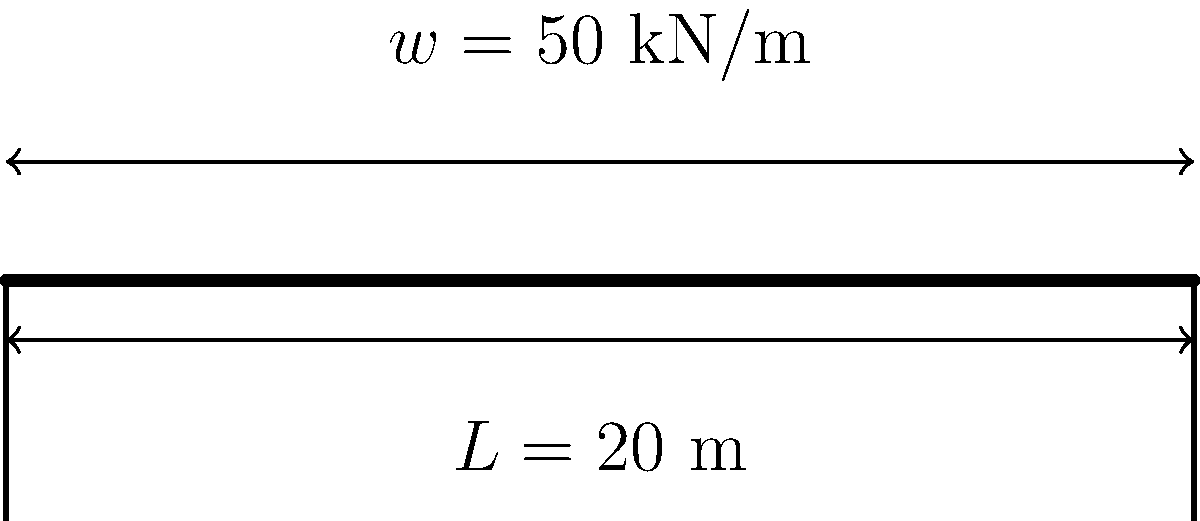A simple supported bridge has a span of 20 meters and is subjected to a uniformly distributed load of 50 kN/m along its entire length. What is the maximum bending moment in the bridge? To calculate the maximum bending moment in a simply supported beam with a uniformly distributed load, we can follow these steps:

1. Identify the given information:
   - Span length, $L = 20$ m
   - Uniformly distributed load, $w = 50$ kN/m

2. The maximum bending moment for a simply supported beam with a uniformly distributed load occurs at the midspan and is given by the formula:

   $M_{max} = \frac{wL^2}{8}$

3. Substitute the values into the formula:

   $M_{max} = \frac{50 \text{ kN/m} \cdot (20 \text{ m})^2}{8}$

4. Calculate:

   $M_{max} = \frac{50 \cdot 400}{8} = \frac{20,000}{8} = 2,500 \text{ kN·m}$

Therefore, the maximum bending moment in the bridge is 2,500 kN·m.
Answer: 2,500 kN·m 